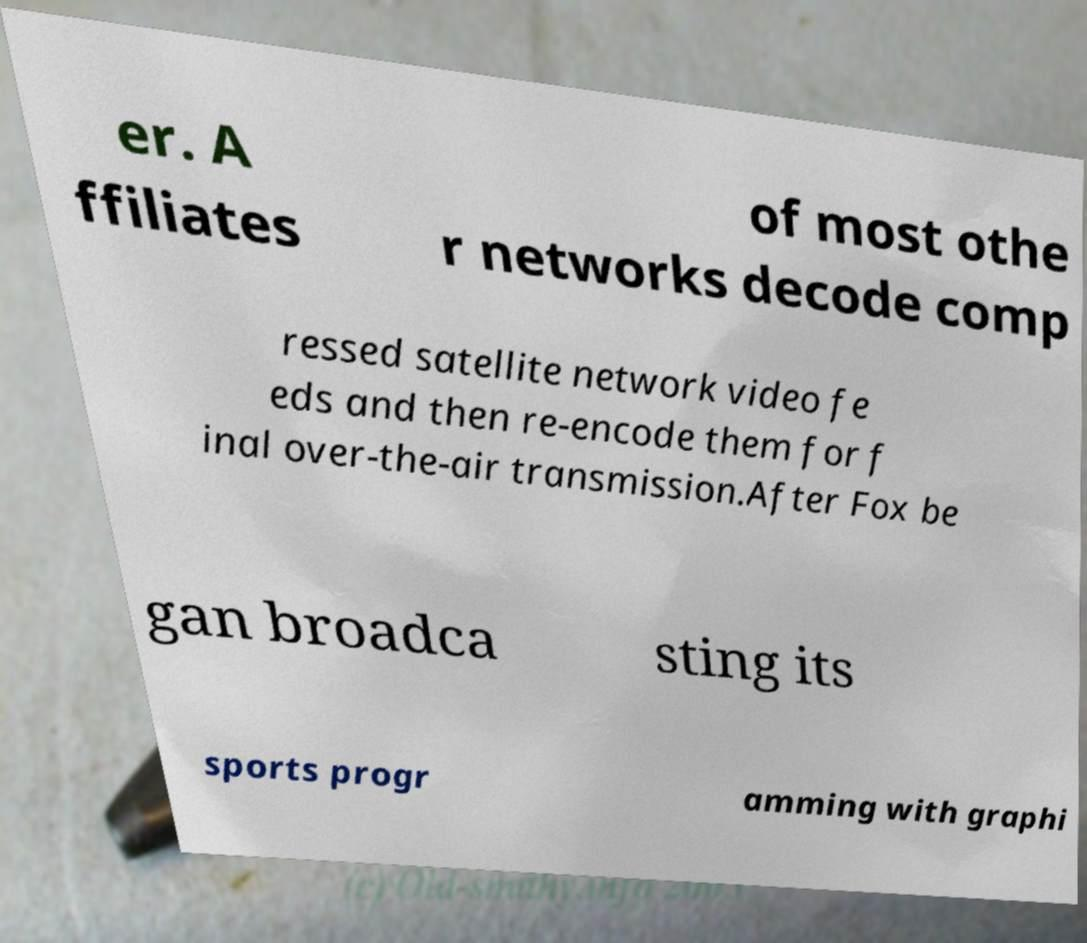Could you extract and type out the text from this image? er. A ffiliates of most othe r networks decode comp ressed satellite network video fe eds and then re-encode them for f inal over-the-air transmission.After Fox be gan broadca sting its sports progr amming with graphi 